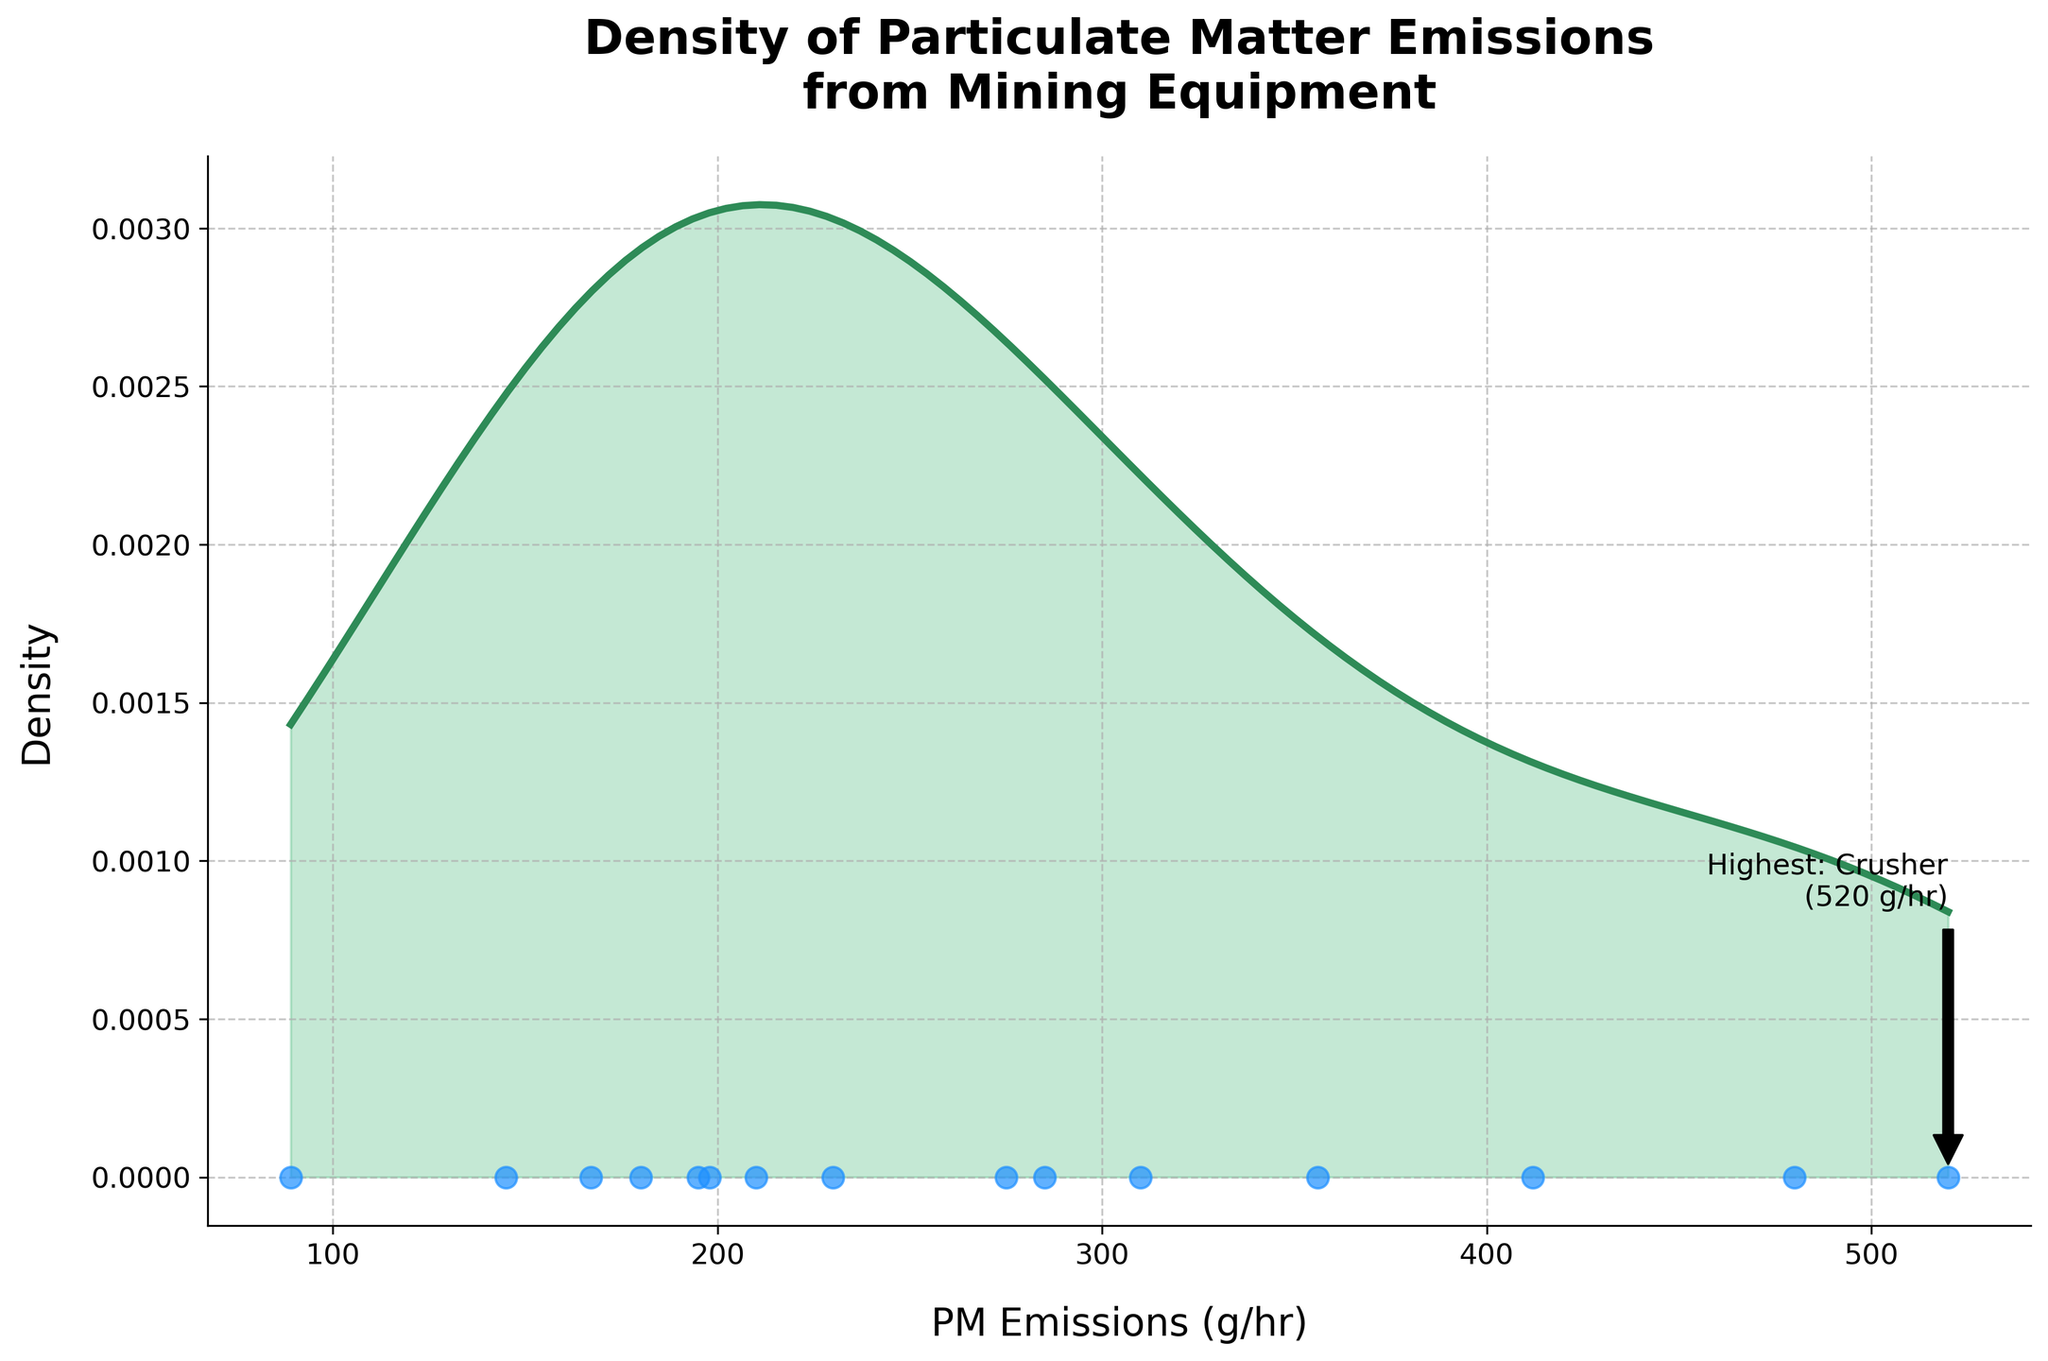What's the title of the plot? The title of the plot is clearly displayed at the top of the figure which reads 'Density of Particulate Matter Emissions from Mining Equipment'.
Answer: Density of Particulate Matter Emissions from Mining Equipment What does the x-axis represent? By looking at the label on the x-axis, it is clear that it represents 'PM Emissions (g/hr)'.
Answer: PM Emissions (g/hr) Which piece of equipment has the highest PM emissions? The plot annotates the highest emission, specifying a point on the far right highlighted with an arrow. The text indicates the equipment with the highest emissions is the Crusher with 520 g/hr.
Answer: Crusher What is the estimated density value near the highest emission rate? By examining the peak density curve at the position corresponding to the highest emission rate (520 g/hr), we see the density value annotated by the arrow.
Answer: Very low (near 0) What does the y-axis represent? The y-axis is labeled 'Density', indicating it measures the density of particulate matter emissions.
Answer: Density Which equipment has PM emissions close to 300 g/hr? By observing the scatter plot along the x-axis, emissions around 300 g/hr correspond to Rock Breaker (310 g/hr) and Bulldozer (356 g/hr) which are closest.
Answer: Rock Breaker and Bulldozer How does the density of emissions change as you move from low to high PM emission rates? By looking at the density plot, it starts high and smooth at lower emissions, peaks around midrange emissions, and tapers off towards higher emissions.
Answer: Starts high and smooth, peaks at mid, tapers off at high What is the range of PM emissions displayed in the plot? The x-axis range covers from the minimum emission of the Conveyor Belt (89 g/hr) to the maximum of the Crusher (520 g/hr).
Answer: 89 g/hr to 520 g/hr How many data points are there in the figure? The scatter plot shows blue dots along the x-axis, each representing a data point for a type of equipment. Counting these dots, we get 15 data points.
Answer: 15 Is there a significant spread in PM emissions across different types of equipment? Observing the spread of the scatter points along the x-axis, they range from relatively low values of 89 g/hr to a high of 520 g/hr, showing a significant spread.
Answer: Yes 